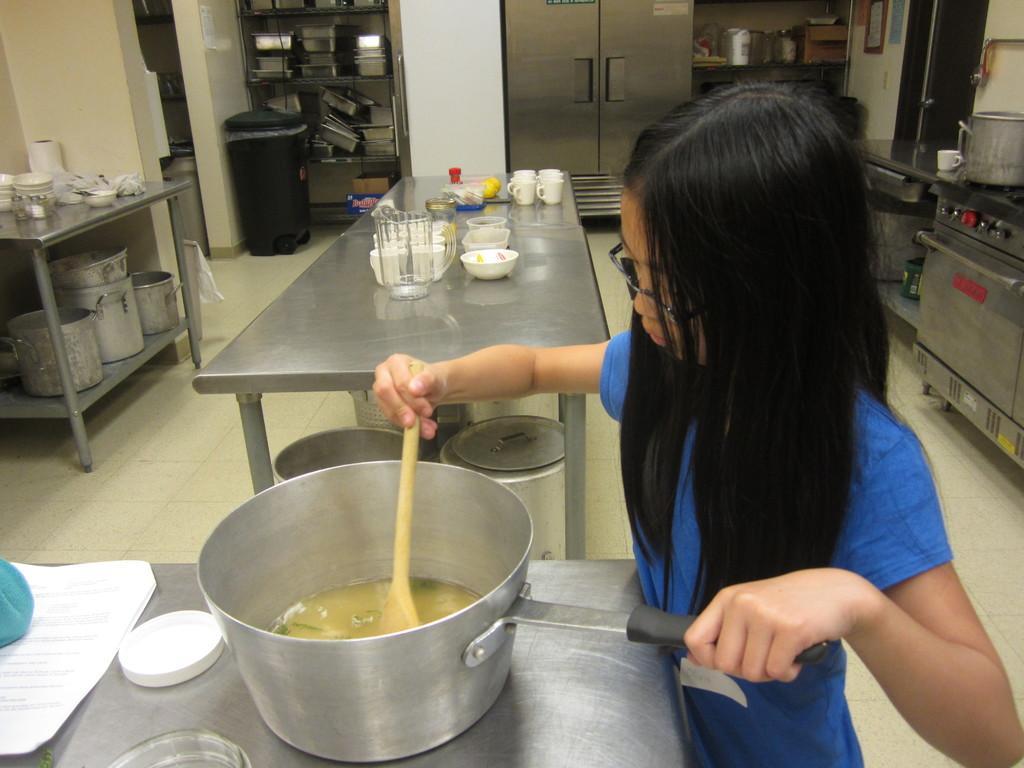Can you describe this image briefly? This picture is taken in the kitchen. In this image, on the right side, we can see a girl standing in front of the table and holding pan on one hand and stick on the other hand. On the table, we can also see hand of a person, paper. On the left side of the table, we can see a bowl and a cap. On the right side, we can also see another table, on that table, we can see a jar and a cup. On the left side, we can see another table, on that table, we can see some bowls, cups, tissues, under the table, we can see some jars. In the background, we can also see a table, on that table, we can see some jars, cups, bowl. In the background, we can also see a dustbin, a shelf with some metal instrument, refrigerator, we can also see another shelf with some metal instrument and a wall with some photo frames attached to it. At the bottom, we can see a floor. 